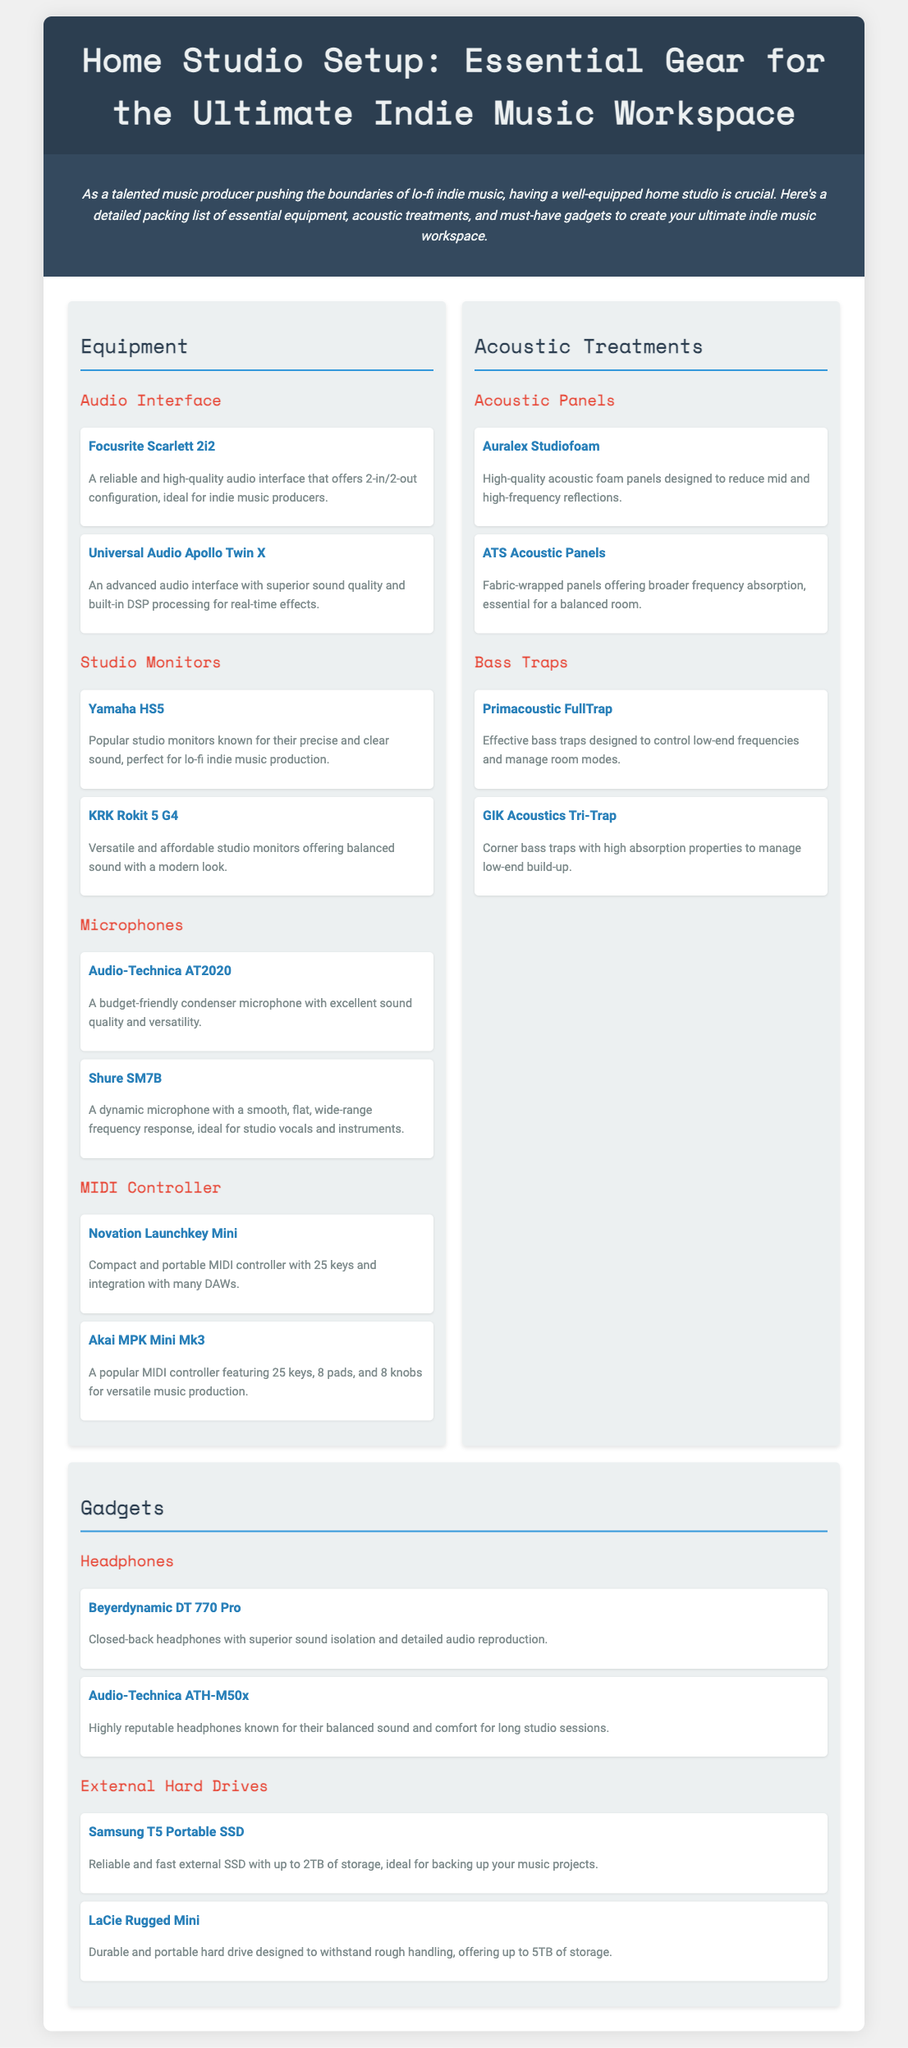What is the first item listed under Audio Interface? The first item in the Audio Interface section is "Focusrite Scarlett 2i2."
Answer: Focusrite Scarlett 2i2 How many studio monitors are listed? There are four studio monitors mentioned in the document.
Answer: Four What type of microphone is the Shure SM7B? The Shure SM7B is categorized as a dynamic microphone in the document.
Answer: Dynamic Which acoustic panel is described as "High-quality acoustic foam panels"? The Auralex Studiofoam is labeled as high-quality acoustic foam panels.
Answer: Auralex Studiofoam What is the storage capacity of the Samsung T5 Portable SSD? The Samsung T5 Portable SSD has storage options of up to 2TB as stated in the document.
Answer: Up to 2TB What are the recommended headphones for sound isolation? The Beyerdynamic DT 770 Pro is recommended for superior sound isolation.
Answer: Beyerdynamic DT 770 Pro 